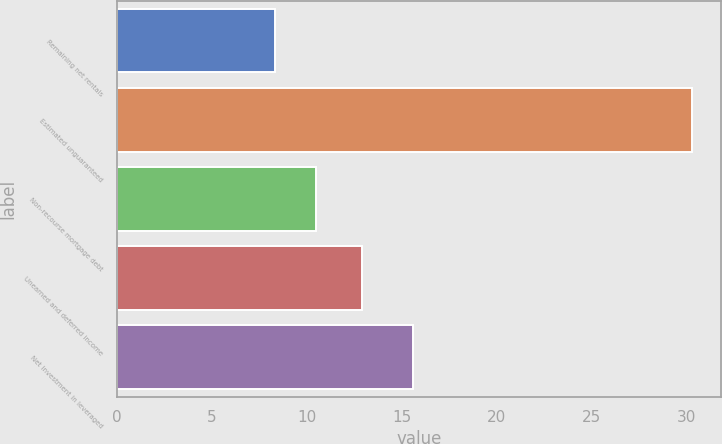Convert chart. <chart><loc_0><loc_0><loc_500><loc_500><bar_chart><fcel>Remaining net rentals<fcel>Estimated unguaranteed<fcel>Non-recourse mortgage debt<fcel>Unearned and deferred income<fcel>Net investment in leveraged<nl><fcel>8.3<fcel>30.3<fcel>10.5<fcel>12.9<fcel>15.6<nl></chart> 